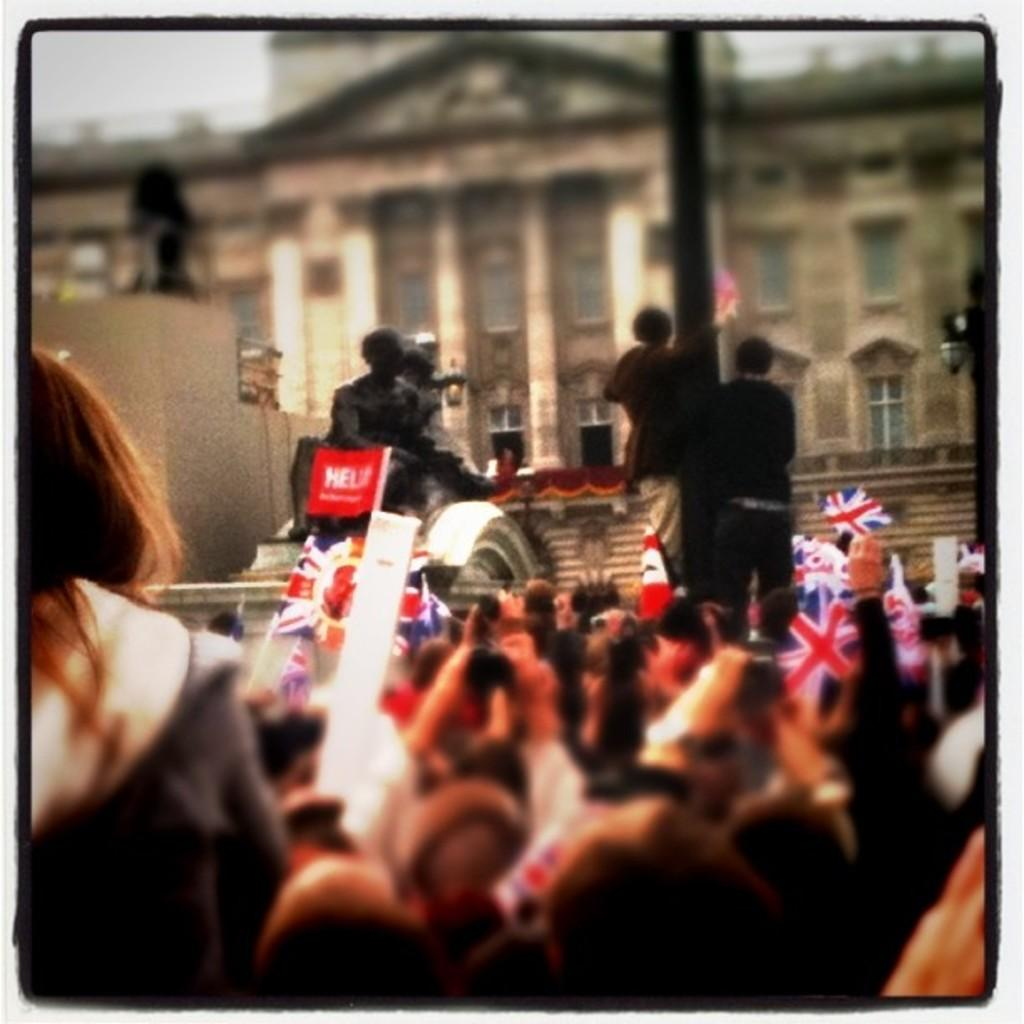What are the people in the image doing? The people in the image are standing and holding flags. What else can be seen in the image besides the people? There are statues and buildings in the image. What book is the person reading in the image? There is no book present in the image; the people are holding flags. What trick is the statue performing in the image? There is no trick being performed by the statue in the image; it is a stationary object. 